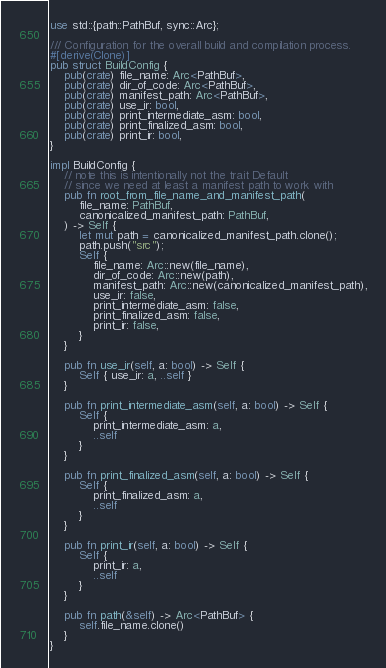Convert code to text. <code><loc_0><loc_0><loc_500><loc_500><_Rust_>use std::{path::PathBuf, sync::Arc};

/// Configuration for the overall build and compilation process.
#[derive(Clone)]
pub struct BuildConfig {
    pub(crate) file_name: Arc<PathBuf>,
    pub(crate) dir_of_code: Arc<PathBuf>,
    pub(crate) manifest_path: Arc<PathBuf>,
    pub(crate) use_ir: bool,
    pub(crate) print_intermediate_asm: bool,
    pub(crate) print_finalized_asm: bool,
    pub(crate) print_ir: bool,
}

impl BuildConfig {
    // note this is intentionally not the trait Default
    // since we need at least a manifest path to work with
    pub fn root_from_file_name_and_manifest_path(
        file_name: PathBuf,
        canonicalized_manifest_path: PathBuf,
    ) -> Self {
        let mut path = canonicalized_manifest_path.clone();
        path.push("src");
        Self {
            file_name: Arc::new(file_name),
            dir_of_code: Arc::new(path),
            manifest_path: Arc::new(canonicalized_manifest_path),
            use_ir: false,
            print_intermediate_asm: false,
            print_finalized_asm: false,
            print_ir: false,
        }
    }

    pub fn use_ir(self, a: bool) -> Self {
        Self { use_ir: a, ..self }
    }

    pub fn print_intermediate_asm(self, a: bool) -> Self {
        Self {
            print_intermediate_asm: a,
            ..self
        }
    }

    pub fn print_finalized_asm(self, a: bool) -> Self {
        Self {
            print_finalized_asm: a,
            ..self
        }
    }

    pub fn print_ir(self, a: bool) -> Self {
        Self {
            print_ir: a,
            ..self
        }
    }

    pub fn path(&self) -> Arc<PathBuf> {
        self.file_name.clone()
    }
}
</code> 